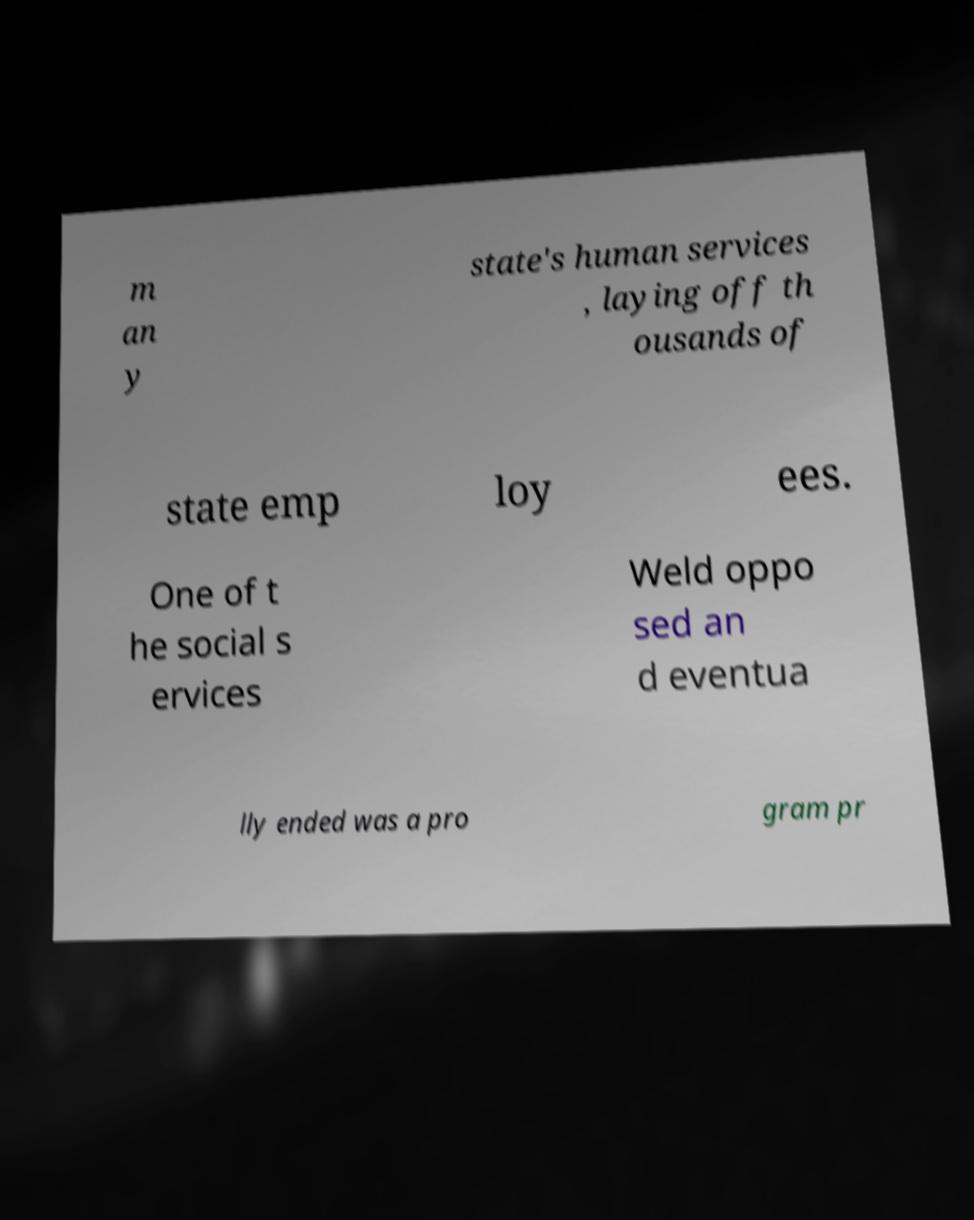Could you assist in decoding the text presented in this image and type it out clearly? m an y state's human services , laying off th ousands of state emp loy ees. One of t he social s ervices Weld oppo sed an d eventua lly ended was a pro gram pr 